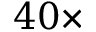<formula> <loc_0><loc_0><loc_500><loc_500>4 0 \times</formula> 